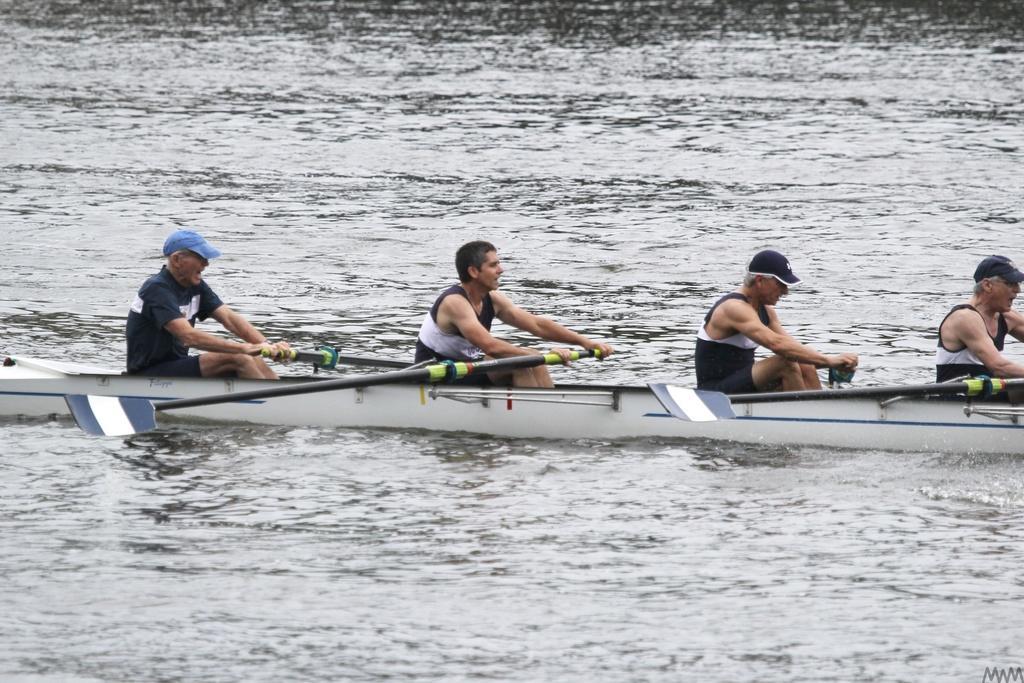Can you describe this image briefly? In the picture I can see people are sitting on a boat and holding objects in hands. I can also see oars are attached to the boat. Some of the people are wearing caps. 